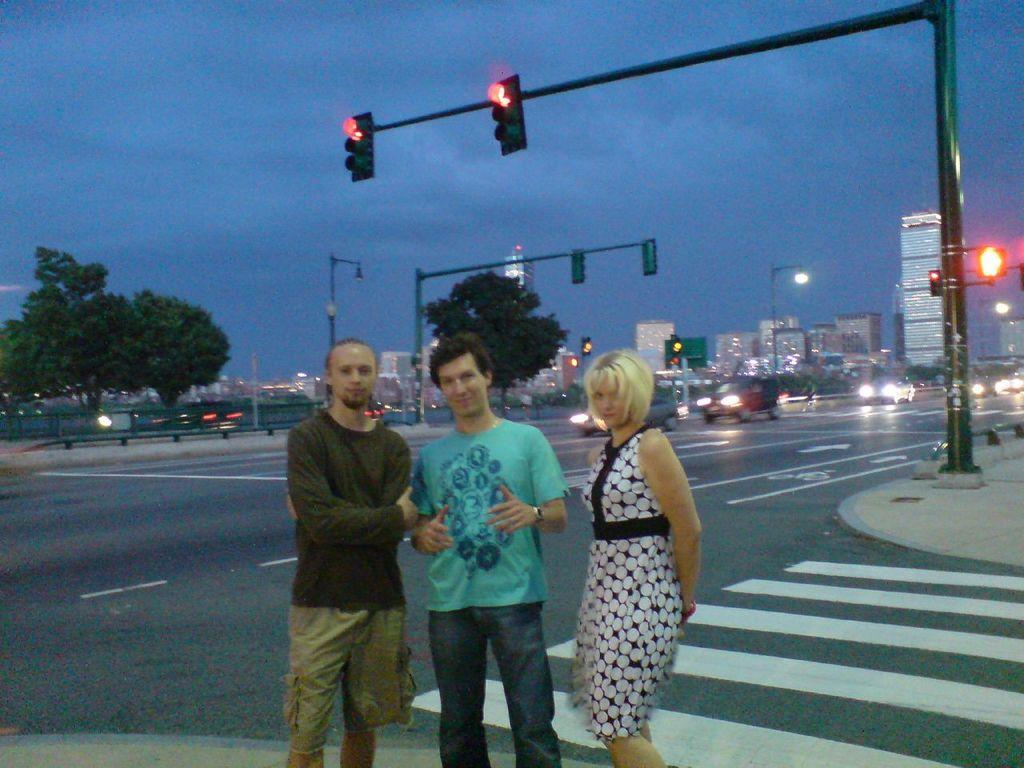How would you summarize this image in a sentence or two? In this picture I can see few people are standing side of the road, behind there are few vehicles on the road, signal lights, background I can see some buildings and trees. 